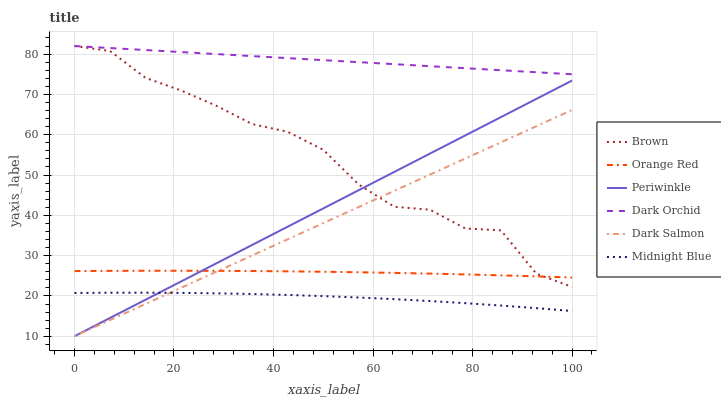Does Midnight Blue have the minimum area under the curve?
Answer yes or no. Yes. Does Dark Orchid have the maximum area under the curve?
Answer yes or no. Yes. Does Dark Salmon have the minimum area under the curve?
Answer yes or no. No. Does Dark Salmon have the maximum area under the curve?
Answer yes or no. No. Is Dark Salmon the smoothest?
Answer yes or no. Yes. Is Brown the roughest?
Answer yes or no. Yes. Is Midnight Blue the smoothest?
Answer yes or no. No. Is Midnight Blue the roughest?
Answer yes or no. No. Does Dark Salmon have the lowest value?
Answer yes or no. Yes. Does Midnight Blue have the lowest value?
Answer yes or no. No. Does Dark Orchid have the highest value?
Answer yes or no. Yes. Does Dark Salmon have the highest value?
Answer yes or no. No. Is Midnight Blue less than Orange Red?
Answer yes or no. Yes. Is Brown greater than Midnight Blue?
Answer yes or no. Yes. Does Orange Red intersect Brown?
Answer yes or no. Yes. Is Orange Red less than Brown?
Answer yes or no. No. Is Orange Red greater than Brown?
Answer yes or no. No. Does Midnight Blue intersect Orange Red?
Answer yes or no. No. 